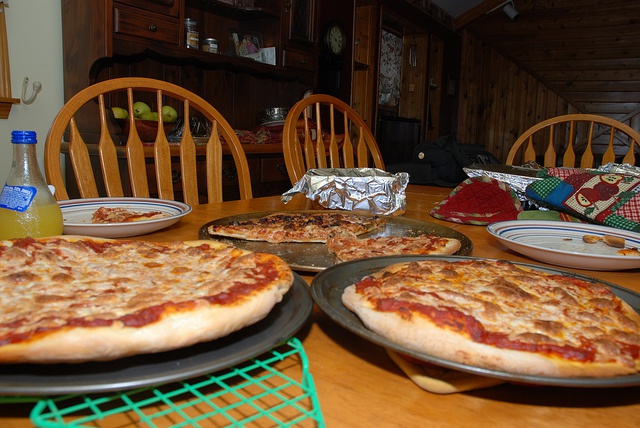Describe the objects in this image and their specific colors. I can see pizza in gray, tan, and brown tones, pizza in gray, brown, and tan tones, chair in gray, brown, black, maroon, and olive tones, dining table in gray, red, orange, and maroon tones, and chair in gray, maroon, black, and brown tones in this image. 